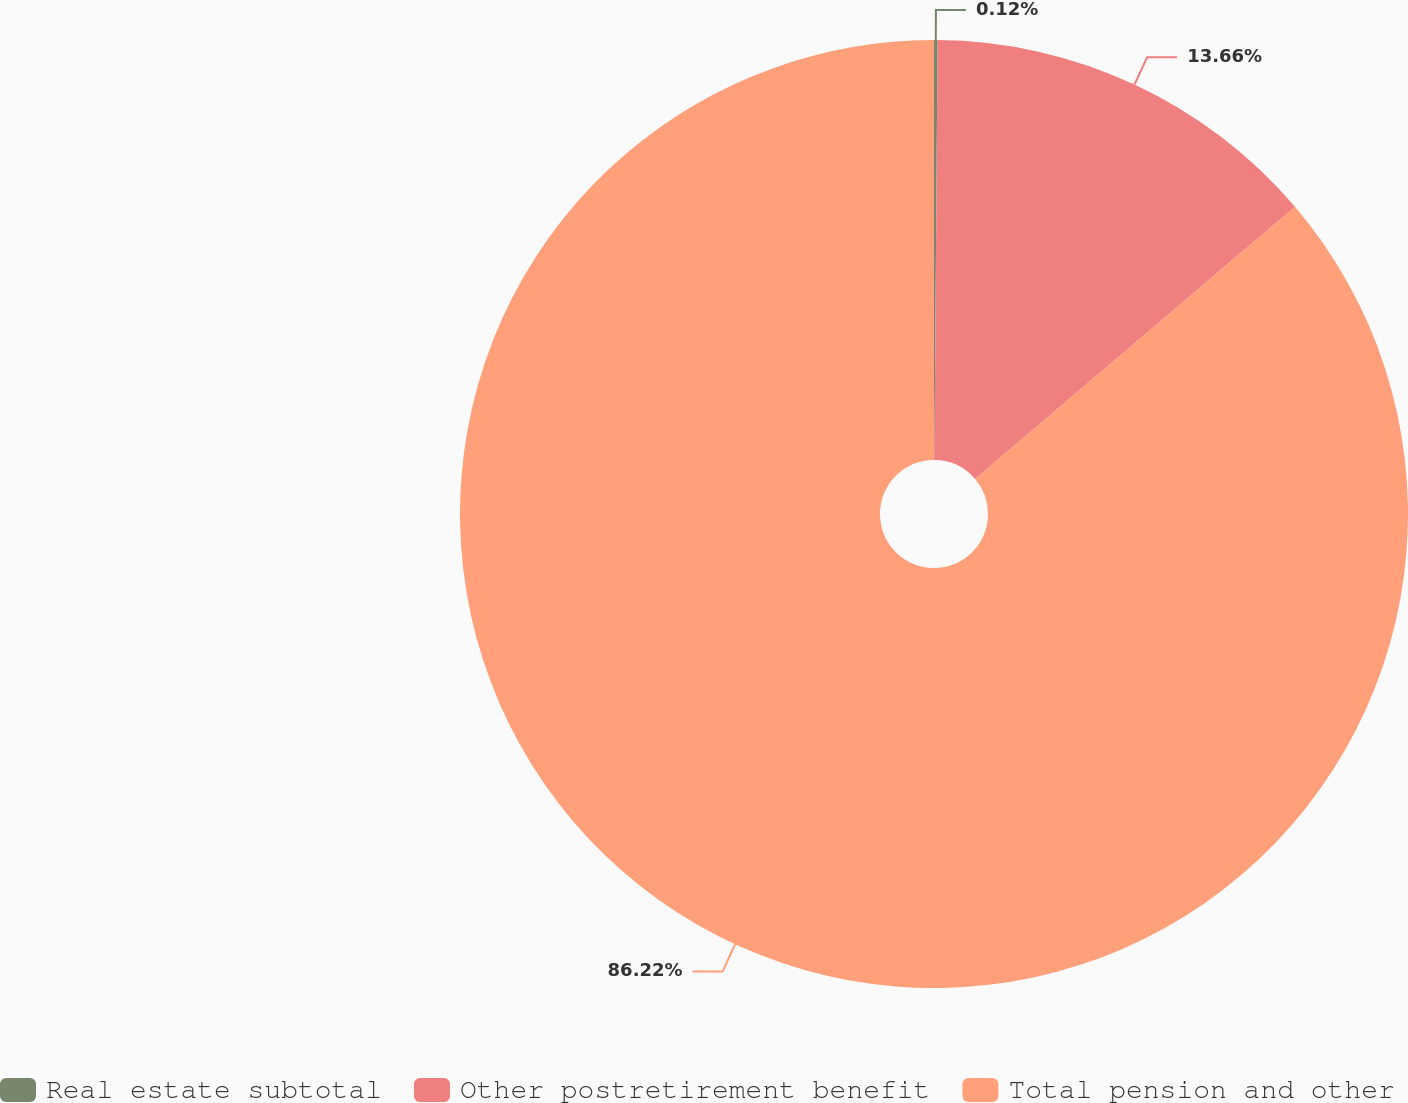Convert chart. <chart><loc_0><loc_0><loc_500><loc_500><pie_chart><fcel>Real estate subtotal<fcel>Other postretirement benefit<fcel>Total pension and other<nl><fcel>0.12%<fcel>13.66%<fcel>86.22%<nl></chart> 